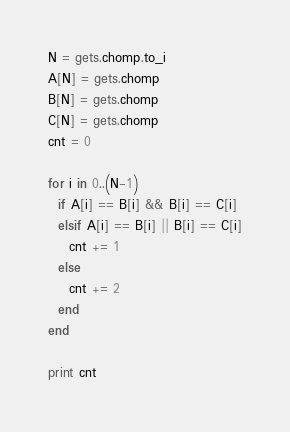<code> <loc_0><loc_0><loc_500><loc_500><_Ruby_>N = gets.chomp.to_i
A[N] = gets.chomp
B[N] = gets.chomp
C[N] = gets.chomp
cnt = 0

for i in 0..(N-1)
  if A[i] == B[i] && B[i] == C[i]
  elsif A[i] == B[i] || B[i] == C[i]
    cnt += 1
  else
    cnt += 2
  end
end

print cnt</code> 